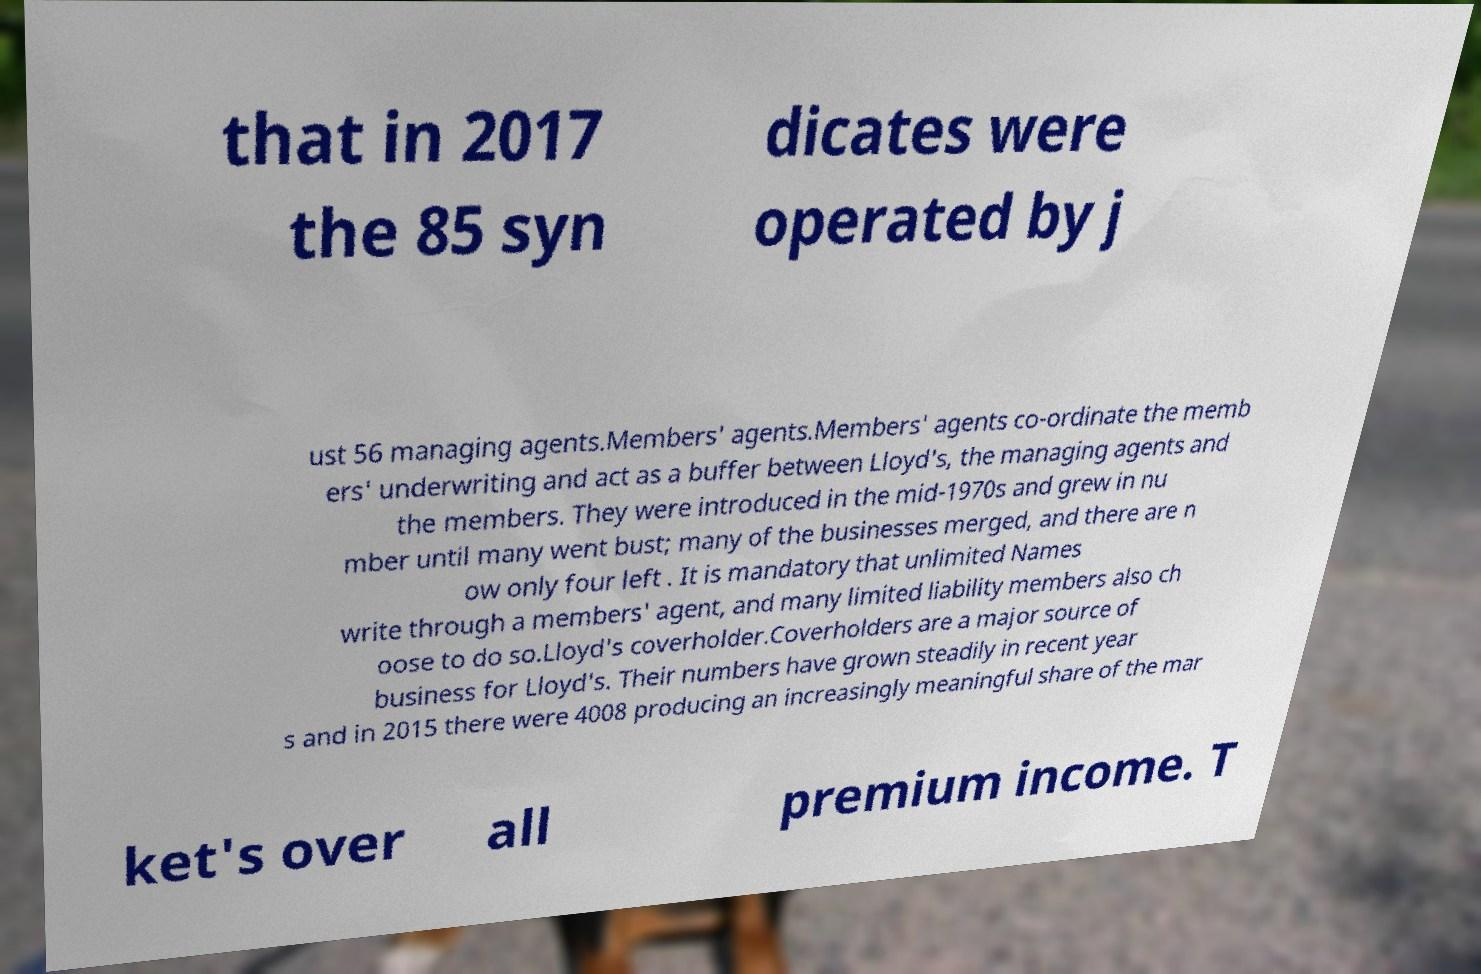Could you assist in decoding the text presented in this image and type it out clearly? that in 2017 the 85 syn dicates were operated by j ust 56 managing agents.Members' agents.Members' agents co-ordinate the memb ers' underwriting and act as a buffer between Lloyd's, the managing agents and the members. They were introduced in the mid-1970s and grew in nu mber until many went bust; many of the businesses merged, and there are n ow only four left . It is mandatory that unlimited Names write through a members' agent, and many limited liability members also ch oose to do so.Lloyd's coverholder.Coverholders are a major source of business for Lloyd's. Their numbers have grown steadily in recent year s and in 2015 there were 4008 producing an increasingly meaningful share of the mar ket's over all premium income. T 